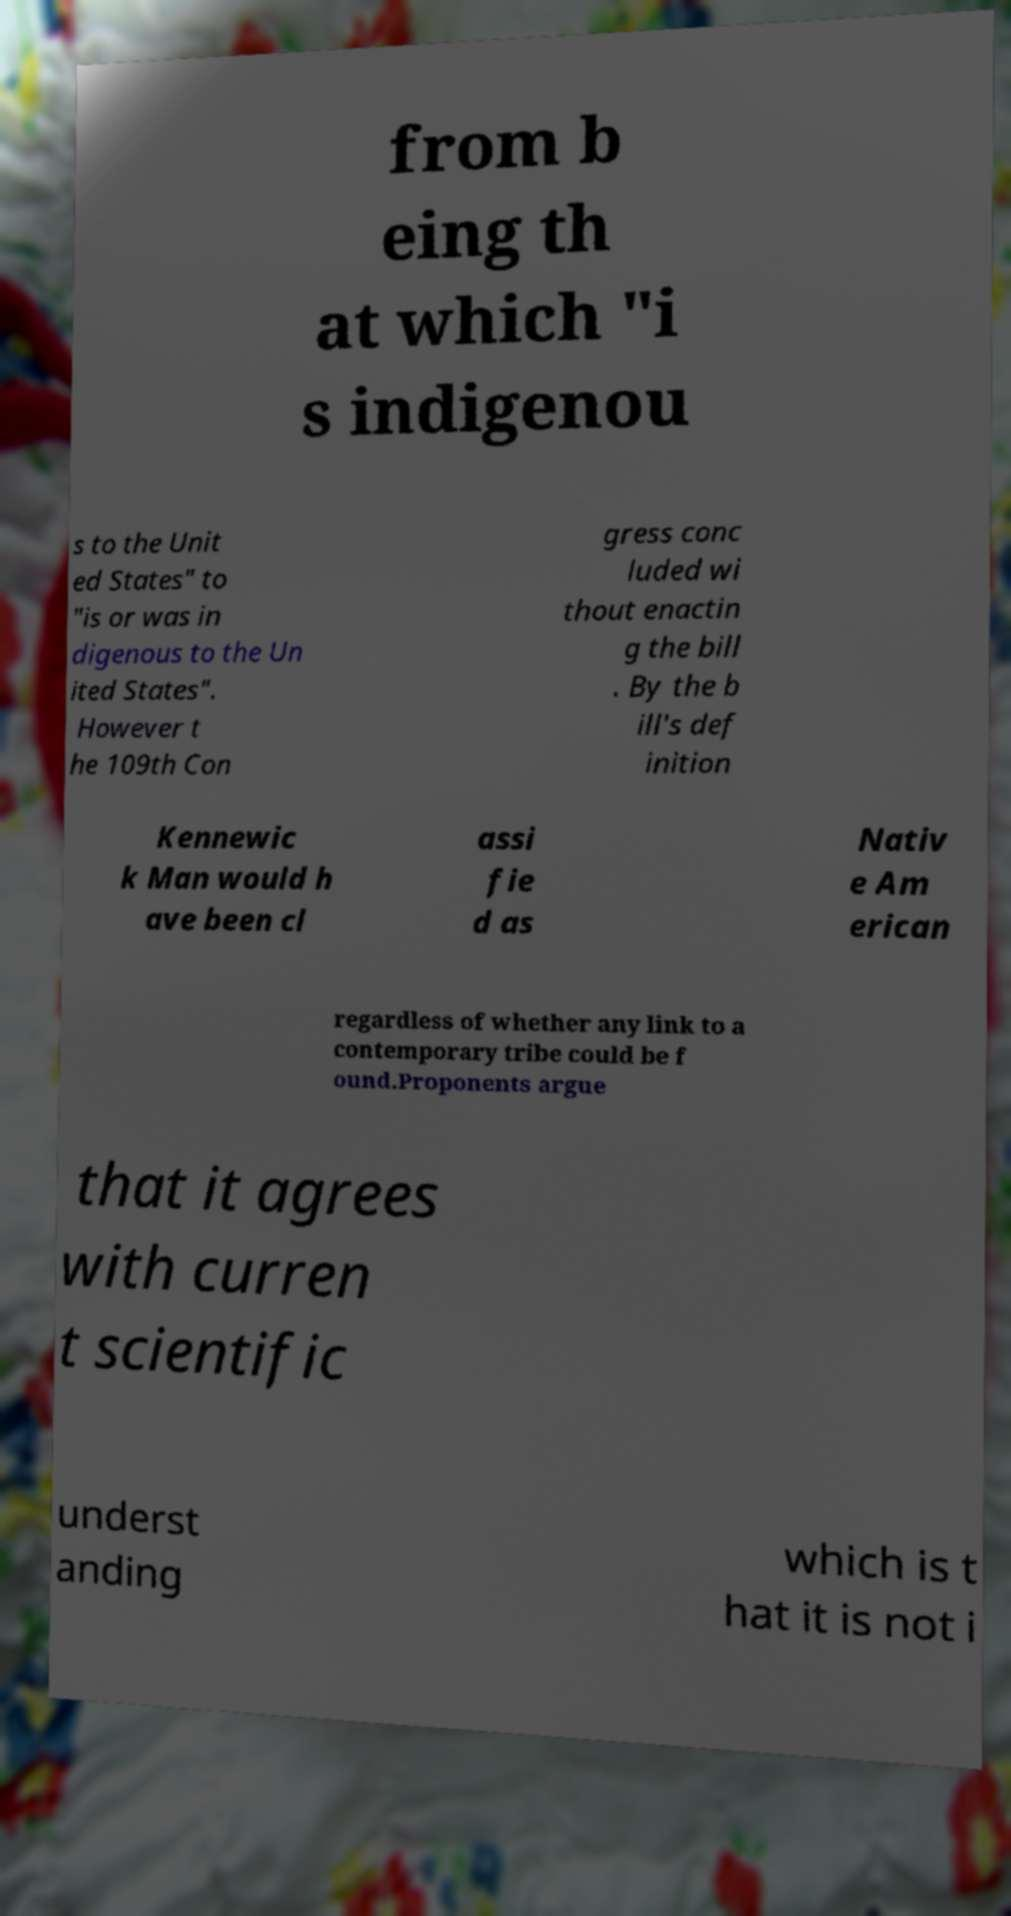Please identify and transcribe the text found in this image. from b eing th at which "i s indigenou s to the Unit ed States" to "is or was in digenous to the Un ited States". However t he 109th Con gress conc luded wi thout enactin g the bill . By the b ill's def inition Kennewic k Man would h ave been cl assi fie d as Nativ e Am erican regardless of whether any link to a contemporary tribe could be f ound.Proponents argue that it agrees with curren t scientific underst anding which is t hat it is not i 